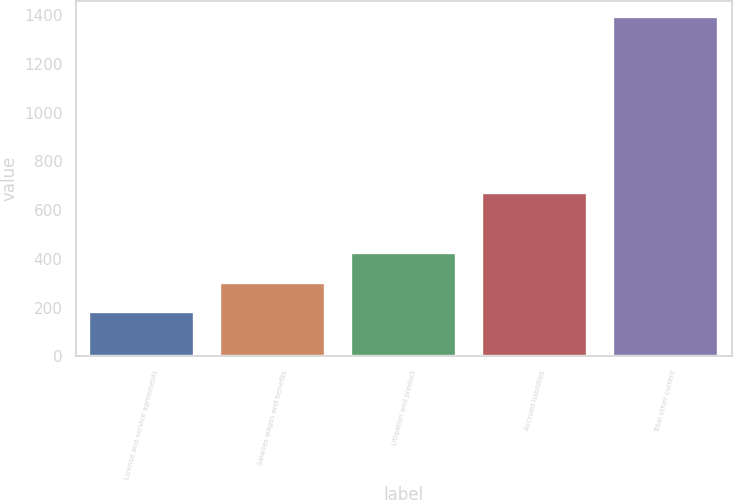<chart> <loc_0><loc_0><loc_500><loc_500><bar_chart><fcel>License and service agreements<fcel>Salaries wages and benefits<fcel>Litigation and product<fcel>Accrued liabilities<fcel>Total other current<nl><fcel>181.8<fcel>302.75<fcel>423.7<fcel>670.6<fcel>1391.3<nl></chart> 